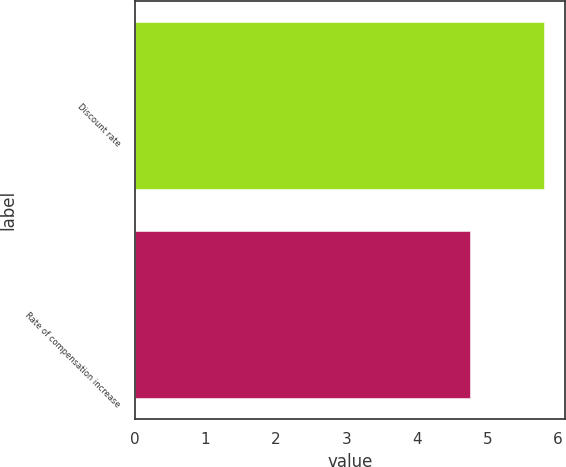Convert chart to OTSL. <chart><loc_0><loc_0><loc_500><loc_500><bar_chart><fcel>Discount rate<fcel>Rate of compensation increase<nl><fcel>5.81<fcel>4.75<nl></chart> 